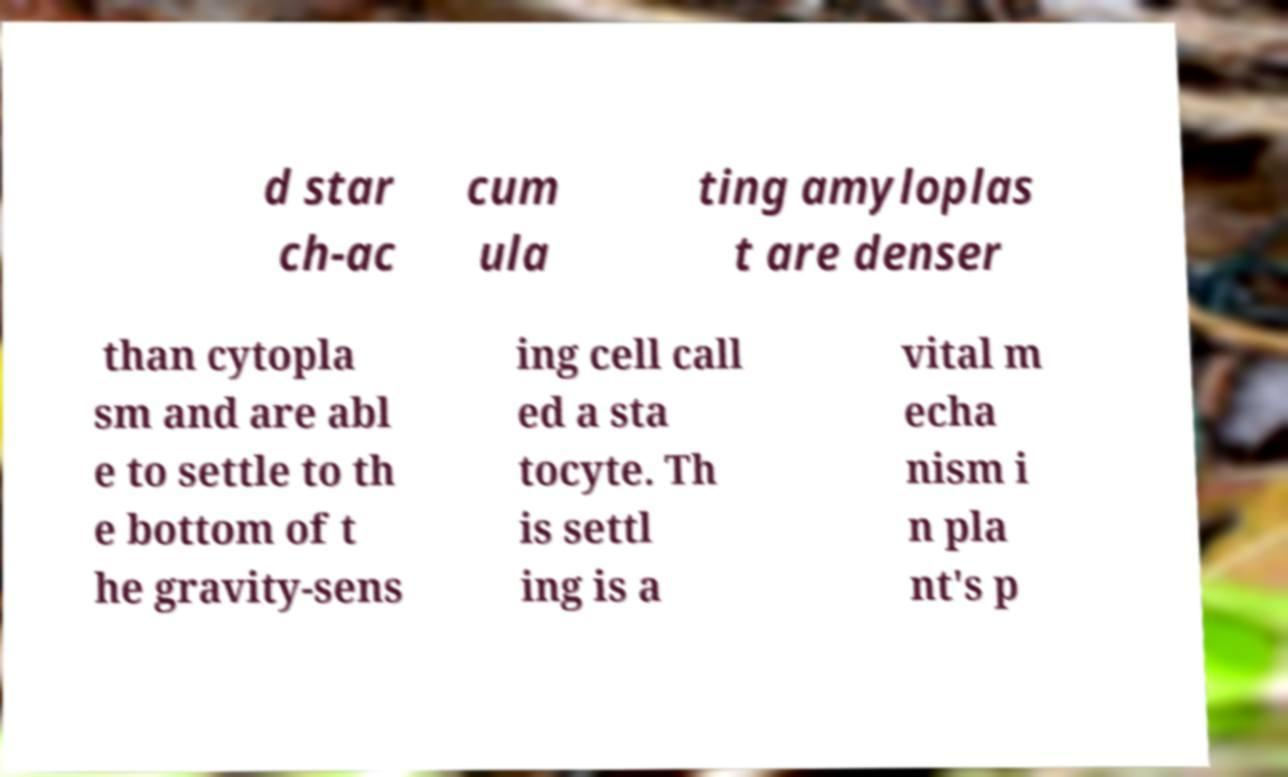There's text embedded in this image that I need extracted. Can you transcribe it verbatim? d star ch-ac cum ula ting amyloplas t are denser than cytopla sm and are abl e to settle to th e bottom of t he gravity-sens ing cell call ed a sta tocyte. Th is settl ing is a vital m echa nism i n pla nt's p 